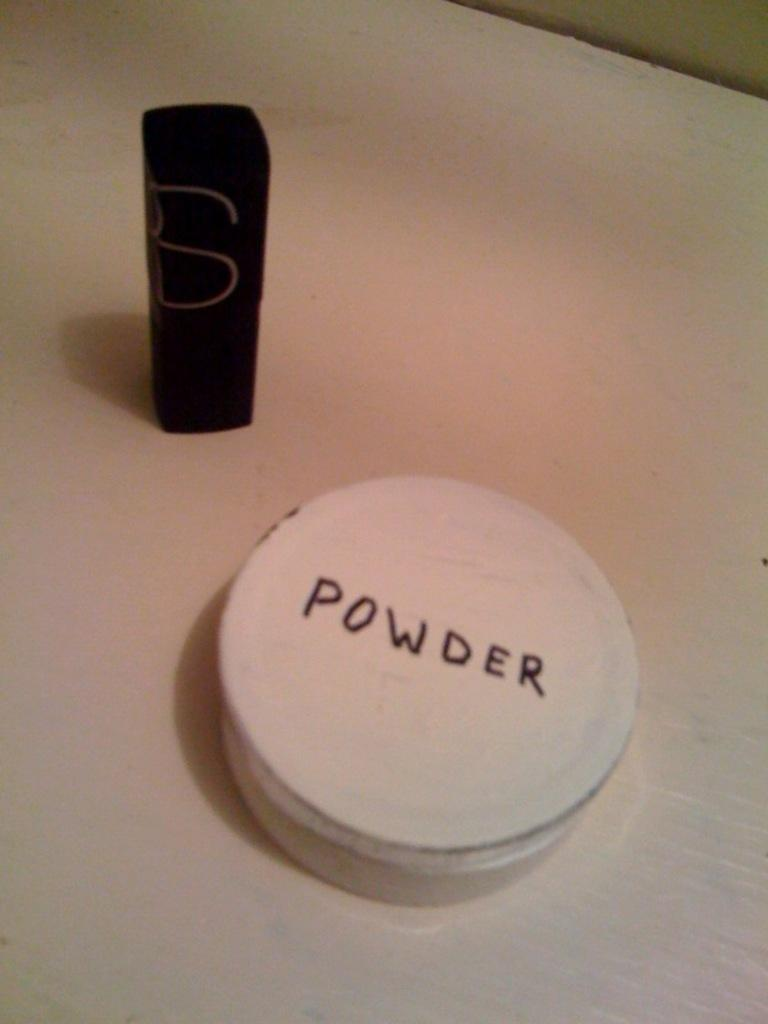<image>
Give a short and clear explanation of the subsequent image. A container that says "Powder" on top of it. 